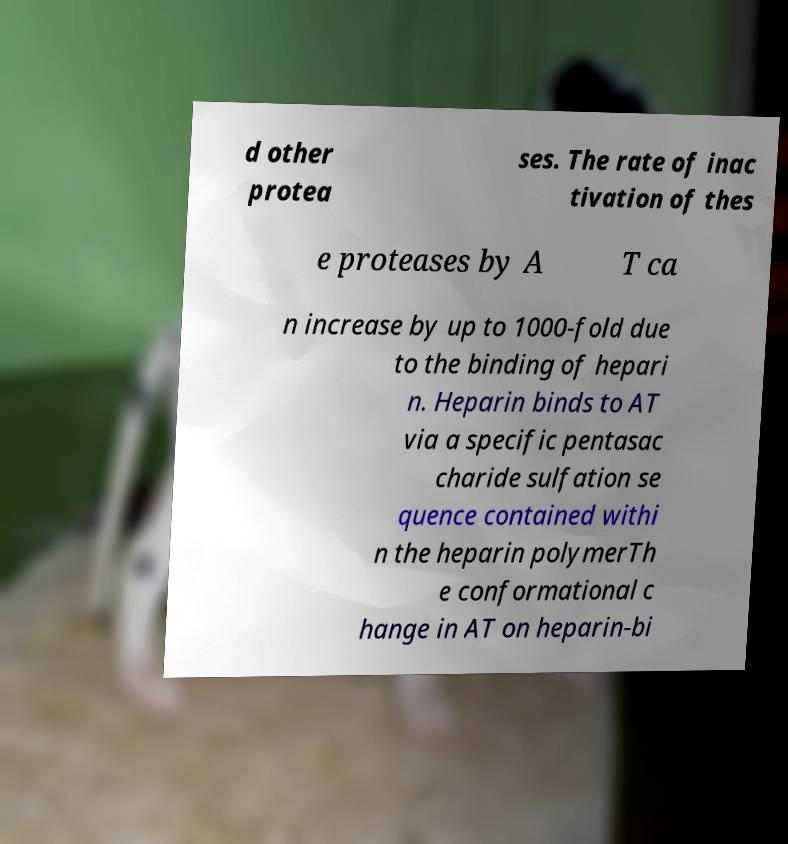Can you accurately transcribe the text from the provided image for me? d other protea ses. The rate of inac tivation of thes e proteases by A T ca n increase by up to 1000-fold due to the binding of hepari n. Heparin binds to AT via a specific pentasac charide sulfation se quence contained withi n the heparin polymerTh e conformational c hange in AT on heparin-bi 